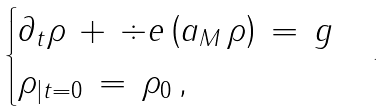<formula> <loc_0><loc_0><loc_500><loc_500>\begin{cases} \partial _ { t } \rho \, + \, \div e \left ( a _ { M } \, \rho \right ) \, = \, g \\ \rho _ { | t = 0 } \, = \, \rho _ { 0 } \, , \end{cases} .</formula> 